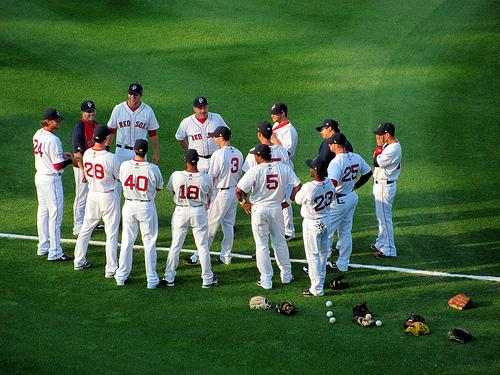Question: where is the picture taken?
Choices:
A. Baseball field.
B. Tennis court.
C. Field.
D. Farm.
Answer with the letter. Answer: A Question: how many baseball players are there?
Choices:
A. Thirteen.
B. Eleven.
C. Twelve.
D. Fourteen.
Answer with the letter. Answer: A Question: what sport do these people play?
Choices:
A. Baseball.
B. Tennis.
C. Frisbee.
D. Swimming.
Answer with the letter. Answer: A Question: who do the players play for?
Choices:
A. Giants.
B. Miami Heats.
C. Super bowl.
D. Red Sox.
Answer with the letter. Answer: D Question: what are all of the men wearing on their head?
Choices:
A. Ball cap.
B. Razor cap.
C. A hat.
D. Fedora.
Answer with the letter. Answer: A 